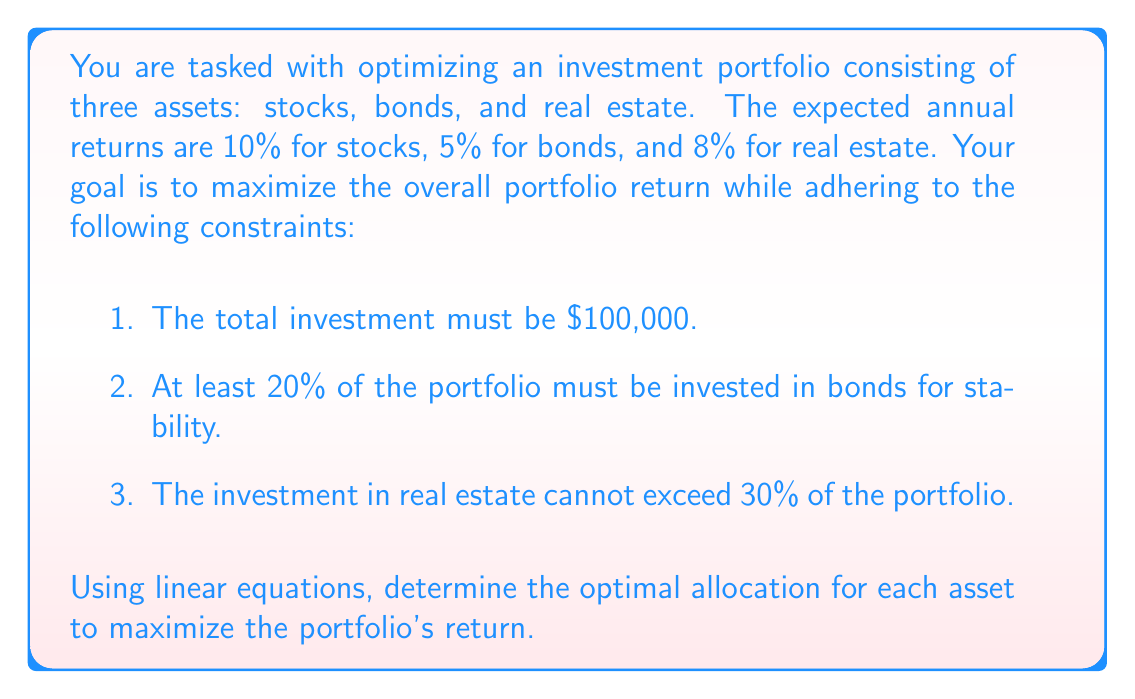Could you help me with this problem? Let's approach this step-by-step using linear programming:

1. Define variables:
   Let $x$ = investment in stocks
   Let $y$ = investment in bonds
   Let $z$ = investment in real estate

2. Objective function (to maximize):
   $$ \text{Return} = 0.10x + 0.05y + 0.08z $$

3. Constraints:
   a. Total investment: $x + y + z = 100000$
   b. Bonds minimum 20%: $y \geq 20000$
   c. Real estate maximum 30%: $z \leq 30000$
   d. Non-negativity: $x, y, z \geq 0$

4. To solve this, we can use the simplex method or a graphical approach. Given the constraints, we can deduce:

   - The maximum allowed for real estate is $30,000 (30%)
   - The minimum for bonds is $20,000 (20%)
   - The remaining $50,000 (50%) should be allocated to stocks for maximum return

5. Let's verify this allocation:
   Stocks (x): $100000 - 30000 - 20000 = 50000$
   Bonds (y): $20000$
   Real estate (z): $30000$

6. Check if it satisfies all constraints:
   - Total: $50000 + 20000 + 30000 = 100000$ ✓
   - Bonds ≥ 20%: $20000 = 20\%$ ✓
   - Real estate ≤ 30%: $30000 = 30\%$ ✓

7. Calculate the return:
   $$ \text{Return} = 0.10(50000) + 0.05(20000) + 0.08(30000) = 8400 $$

This allocation maximizes the return while satisfying all constraints.
Answer: Stocks: $50,000 (50%), Bonds: $20,000 (20%), Real Estate: $30,000 (30%) 